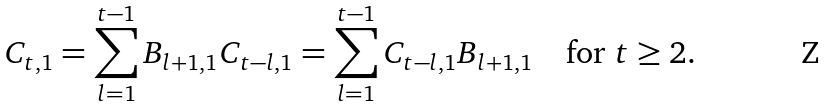<formula> <loc_0><loc_0><loc_500><loc_500>C _ { t , 1 } = \sum _ { l = 1 } ^ { t - 1 } B _ { l + 1 , 1 } C _ { t - l , 1 } = \sum _ { l = 1 } ^ { t - 1 } C _ { t - l , 1 } B _ { l + 1 , 1 } \quad \text {for } t \geq 2 .</formula> 